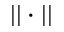Convert formula to latex. <formula><loc_0><loc_0><loc_500><loc_500>| | \cdot | |</formula> 